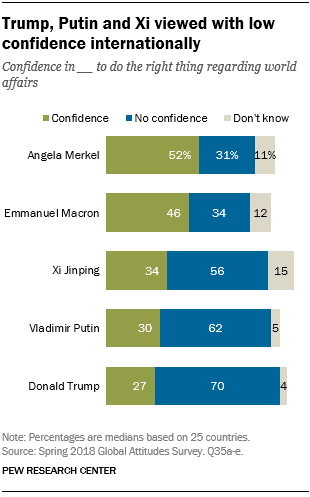List a handful of essential elements in this visual. The program will add all the gray bars in a grid whose values are below 10, starting from the 9th row. The first rightmost bar from the bottom is 4. 